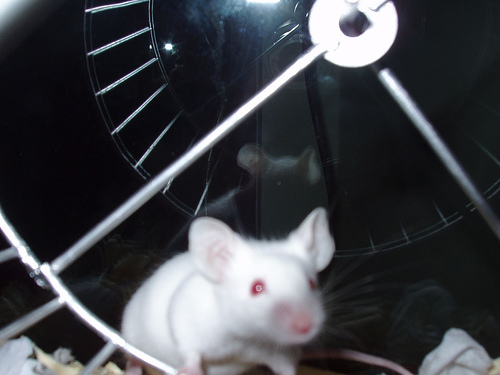<image>
Can you confirm if the mouse is under the wheel? Yes. The mouse is positioned underneath the wheel, with the wheel above it in the vertical space. 